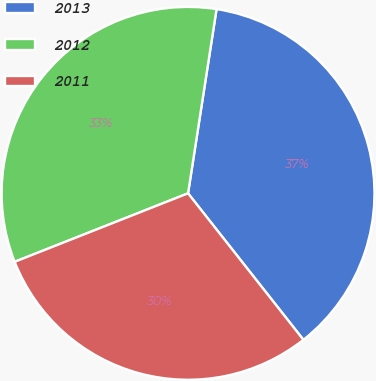<chart> <loc_0><loc_0><loc_500><loc_500><pie_chart><fcel>2013<fcel>2012<fcel>2011<nl><fcel>36.94%<fcel>33.43%<fcel>29.63%<nl></chart> 